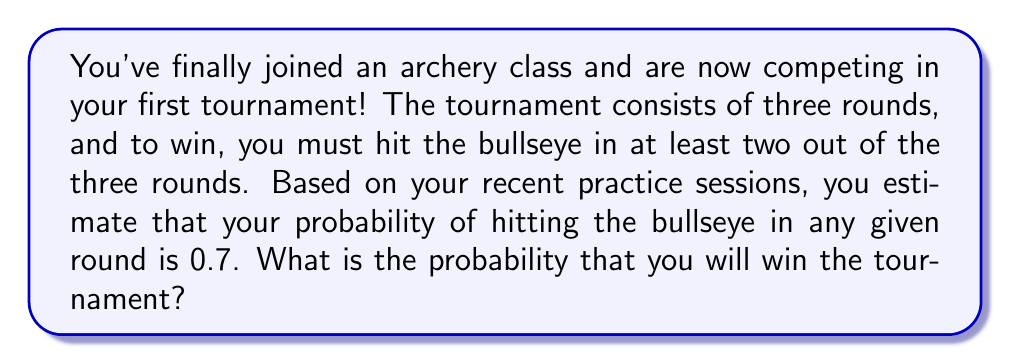Help me with this question. Let's approach this step-by-step:

1) To win the tournament, you need to hit the bullseye in at least 2 out of 3 rounds. This can happen in two ways:
   - You hit the bullseye in all 3 rounds
   - You hit the bullseye in exactly 2 out of 3 rounds

2) Let's calculate the probability of hitting the bullseye in all 3 rounds:
   $P(\text{all 3}) = 0.7 \times 0.7 \times 0.7 = 0.7^3 = 0.343$

3) Now, let's calculate the probability of hitting the bullseye in exactly 2 out of 3 rounds:
   - This can happen in 3 ways: (Success, Success, Failure), (Success, Failure, Success), (Failure, Success, Success)
   - The probability of each of these is: $0.7 \times 0.7 \times 0.3 = 0.147$
   - Since there are 3 such combinations: $P(\text{exactly 2}) = 3 \times 0.147 = 0.441$

4) The total probability of winning is the sum of these two probabilities:
   $P(\text{winning}) = P(\text{all 3}) + P(\text{exactly 2})$
   $P(\text{winning}) = 0.343 + 0.441 = 0.784$

Therefore, the probability of winning the tournament is 0.784 or 78.4%.
Answer: 0.784 